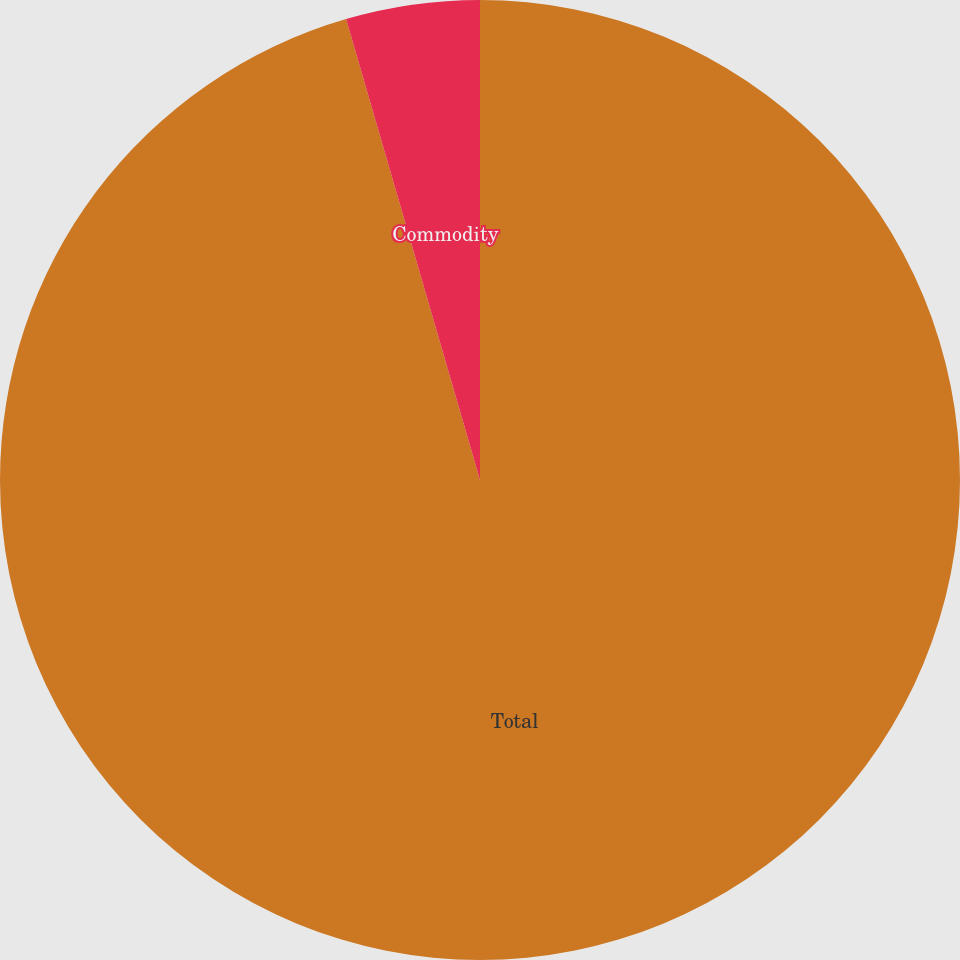Convert chart to OTSL. <chart><loc_0><loc_0><loc_500><loc_500><pie_chart><fcel>Total<fcel>Commodity<nl><fcel>95.5%<fcel>4.5%<nl></chart> 